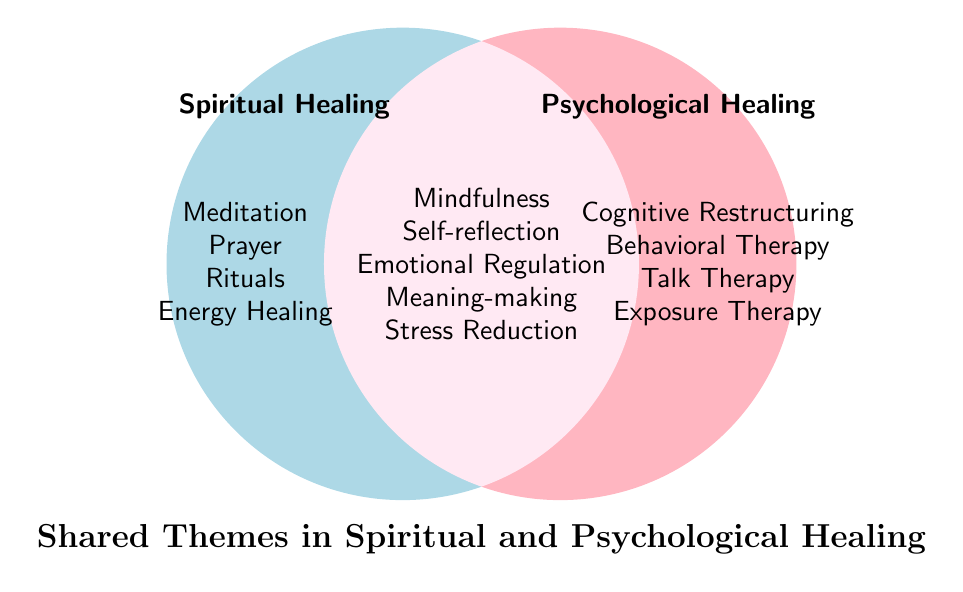How many themes are specific to Spiritual Healing? The figure shows themes in the Spiritual Healing circle that are not in the Shared Themes section. Count them: Meditation, Prayer, Rituals, and Energy Healing.
Answer: 4 Which shared theme appears in both Spiritual and Psychological Healing approaches? Identify the overlapping area of the Venn diagram. The themes listed there are: Mindfulness, Self-reflection, Emotional Regulation, Meaning-making, and Stress Reduction.
Answer: Mindfulness, Self-reflection, Emotional Regulation, Meaning-making, Stress Reduction Are there more themes unique to Psychological Healing or shared between both approaches? Count the themes specific to Psychological Healing: Cognitive Restructuring, Behavioral Therapy, Talk Therapy, and Exposure Therapy. There are 4. Then, count the shared themes: Mindfulness, Self-reflection, Emotional Regulation, Meaning-making, and Stress Reduction. There are 5. Compare these counts.
Answer: Shared themes What are the shared themes focused on emotional well-being? Look at the shared themes in the overlapping area and identify those related to emotional well-being: Emotional Regulation, Meaning-making, and Stress Reduction.
Answer: Emotional Regulation, Meaning-making, Stress Reduction Which healing approach includes Rituals as a theme? Check the themes listed under Spiritual Healing. Rituals is listed there.
Answer: Spiritual Healing How many total unique themes are there, combining both specific and shared themes? Count all unique themes in both circles and the overlapping section: Meditation, Prayer, Rituals, Energy Healing, Cognitive Restructuring, Behavioral Therapy, Talk Therapy, Exposure Therapy, Mindfulness, Self-reflection, Emotional Regulation, Meaning-making, Stress Reduction. There are 13 in total.
Answer: 13 Is Talk Therapy a shared theme? Check if Talk Therapy is listed in the overlapping section. It is not; it is specific to Psychological Healing.
Answer: No Which healing approach emphasizes Cognitive Restructuring? Check where Cognitive Restructuring is listed. It is in the Psychological Healing circle.
Answer: Psychological Healing Is Stress Reduction a unique theme to any specific healing approach? Check if Stress Reduction is in the overlapping area (shared themes) or in a specific circle. It is in the overlapping area.
Answer: No 